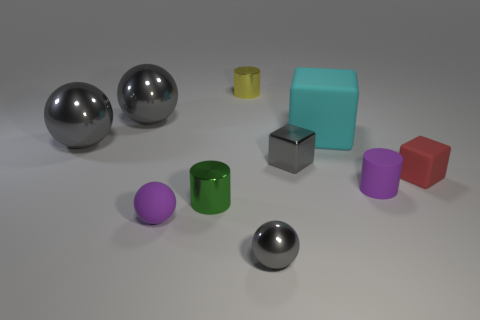Can you describe the texture or finish of the objects? Absolutely. The spherical and cubical objects have a metallic, reflective finish, while the cylindrical objects have a matte finish. 